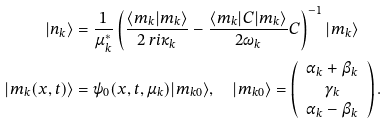Convert formula to latex. <formula><loc_0><loc_0><loc_500><loc_500>| n _ { k } \rangle & = \frac { 1 } { \mu ^ { * } _ { k } } \left ( \frac { \langle m _ { k } | m _ { k } \rangle } { 2 \ r i \kappa _ { k } } - \frac { \langle m _ { k } | C | m _ { k } \rangle } { 2 \omega _ { k } } C \right ) ^ { - 1 } | m _ { k } \rangle \\ | m _ { k } ( x , t ) \rangle & = \psi _ { 0 } ( x , t , \mu _ { k } ) | m _ { k 0 } \rangle , \quad | m _ { k 0 } \rangle = \left ( \begin{array} { c } \alpha _ { k } + \beta _ { k } \\ \gamma _ { k } \\ \alpha _ { k } - \beta _ { k } \end{array} \right ) .</formula> 